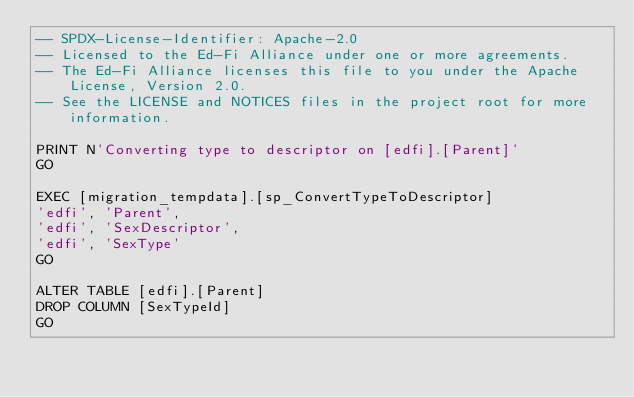<code> <loc_0><loc_0><loc_500><loc_500><_SQL_>-- SPDX-License-Identifier: Apache-2.0
-- Licensed to the Ed-Fi Alliance under one or more agreements.
-- The Ed-Fi Alliance licenses this file to you under the Apache License, Version 2.0.
-- See the LICENSE and NOTICES files in the project root for more information.

PRINT N'Converting type to descriptor on [edfi].[Parent]'
GO

EXEC [migration_tempdata].[sp_ConvertTypeToDescriptor]
'edfi', 'Parent',
'edfi', 'SexDescriptor',
'edfi', 'SexType'
GO

ALTER TABLE [edfi].[Parent]
DROP COLUMN [SexTypeId]
GO

</code> 